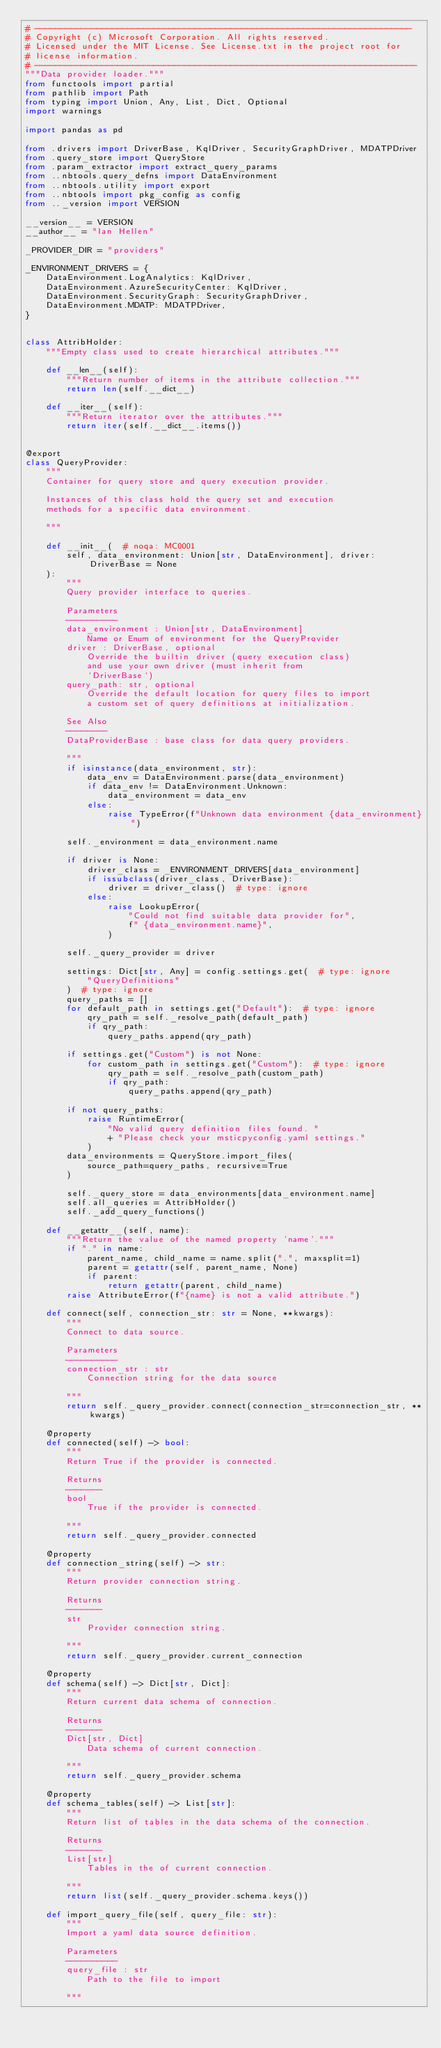Convert code to text. <code><loc_0><loc_0><loc_500><loc_500><_Python_># -------------------------------------------------------------------------
# Copyright (c) Microsoft Corporation. All rights reserved.
# Licensed under the MIT License. See License.txt in the project root for
# license information.
# --------------------------------------------------------------------------
"""Data provider loader."""
from functools import partial
from pathlib import Path
from typing import Union, Any, List, Dict, Optional
import warnings

import pandas as pd

from .drivers import DriverBase, KqlDriver, SecurityGraphDriver, MDATPDriver
from .query_store import QueryStore
from .param_extractor import extract_query_params
from ..nbtools.query_defns import DataEnvironment
from ..nbtools.utility import export
from ..nbtools import pkg_config as config
from .._version import VERSION

__version__ = VERSION
__author__ = "Ian Hellen"

_PROVIDER_DIR = "providers"

_ENVIRONMENT_DRIVERS = {
    DataEnvironment.LogAnalytics: KqlDriver,
    DataEnvironment.AzureSecurityCenter: KqlDriver,
    DataEnvironment.SecurityGraph: SecurityGraphDriver,
    DataEnvironment.MDATP: MDATPDriver,
}


class AttribHolder:
    """Empty class used to create hierarchical attributes."""

    def __len__(self):
        """Return number of items in the attribute collection."""
        return len(self.__dict__)

    def __iter__(self):
        """Return iterator over the attributes."""
        return iter(self.__dict__.items())


@export
class QueryProvider:
    """
    Container for query store and query execution provider.

    Instances of this class hold the query set and execution
    methods for a specific data environment.

    """

    def __init__(  # noqa: MC0001
        self, data_environment: Union[str, DataEnvironment], driver: DriverBase = None
    ):
        """
        Query provider interface to queries.

        Parameters
        ----------
        data_environment : Union[str, DataEnvironment]
            Name or Enum of environment for the QueryProvider
        driver : DriverBase, optional
            Override the builtin driver (query execution class)
            and use your own driver (must inherit from
            `DriverBase`)
        query_path: str, optional
            Override the default location for query files to import
            a custom set of query definitions at initialization.

        See Also
        --------
        DataProviderBase : base class for data query providers.

        """
        if isinstance(data_environment, str):
            data_env = DataEnvironment.parse(data_environment)
            if data_env != DataEnvironment.Unknown:
                data_environment = data_env
            else:
                raise TypeError(f"Unknown data environment {data_environment}")

        self._environment = data_environment.name

        if driver is None:
            driver_class = _ENVIRONMENT_DRIVERS[data_environment]
            if issubclass(driver_class, DriverBase):
                driver = driver_class()  # type: ignore
            else:
                raise LookupError(
                    "Could not find suitable data provider for",
                    f" {data_environment.name}",
                )

        self._query_provider = driver

        settings: Dict[str, Any] = config.settings.get(  # type: ignore
            "QueryDefinitions"
        )  # type: ignore
        query_paths = []
        for default_path in settings.get("Default"):  # type: ignore
            qry_path = self._resolve_path(default_path)
            if qry_path:
                query_paths.append(qry_path)

        if settings.get("Custom") is not None:
            for custom_path in settings.get("Custom"):  # type: ignore
                qry_path = self._resolve_path(custom_path)
                if qry_path:
                    query_paths.append(qry_path)

        if not query_paths:
            raise RuntimeError(
                "No valid query definition files found. "
                + "Please check your msticpyconfig.yaml settings."
            )
        data_environments = QueryStore.import_files(
            source_path=query_paths, recursive=True
        )

        self._query_store = data_environments[data_environment.name]
        self.all_queries = AttribHolder()
        self._add_query_functions()

    def __getattr__(self, name):
        """Return the value of the named property 'name'."""
        if "." in name:
            parent_name, child_name = name.split(".", maxsplit=1)
            parent = getattr(self, parent_name, None)
            if parent:
                return getattr(parent, child_name)
        raise AttributeError(f"{name} is not a valid attribute.")

    def connect(self, connection_str: str = None, **kwargs):
        """
        Connect to data source.

        Parameters
        ----------
        connection_str : str
            Connection string for the data source

        """
        return self._query_provider.connect(connection_str=connection_str, **kwargs)

    @property
    def connected(self) -> bool:
        """
        Return True if the provider is connected.

        Returns
        -------
        bool
            True if the provider is connected.

        """
        return self._query_provider.connected

    @property
    def connection_string(self) -> str:
        """
        Return provider connection string.

        Returns
        -------
        str
            Provider connection string.

        """
        return self._query_provider.current_connection

    @property
    def schema(self) -> Dict[str, Dict]:
        """
        Return current data schema of connection.

        Returns
        -------
        Dict[str, Dict]
            Data schema of current connection.

        """
        return self._query_provider.schema

    @property
    def schema_tables(self) -> List[str]:
        """
        Return list of tables in the data schema of the connection.

        Returns
        -------
        List[str]
            Tables in the of current connection.

        """
        return list(self._query_provider.schema.keys())

    def import_query_file(self, query_file: str):
        """
        Import a yaml data source definition.

        Parameters
        ----------
        query_file : str
            Path to the file to import

        """</code> 